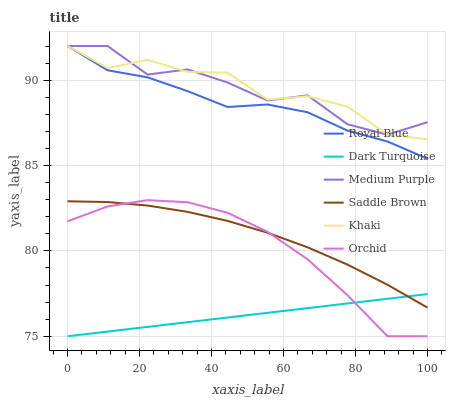Does Medium Purple have the minimum area under the curve?
Answer yes or no. No. Does Medium Purple have the maximum area under the curve?
Answer yes or no. No. Is Medium Purple the smoothest?
Answer yes or no. No. Is Dark Turquoise the roughest?
Answer yes or no. No. Does Medium Purple have the lowest value?
Answer yes or no. No. Does Dark Turquoise have the highest value?
Answer yes or no. No. Is Saddle Brown less than Khaki?
Answer yes or no. Yes. Is Medium Purple greater than Orchid?
Answer yes or no. Yes. Does Saddle Brown intersect Khaki?
Answer yes or no. No. 